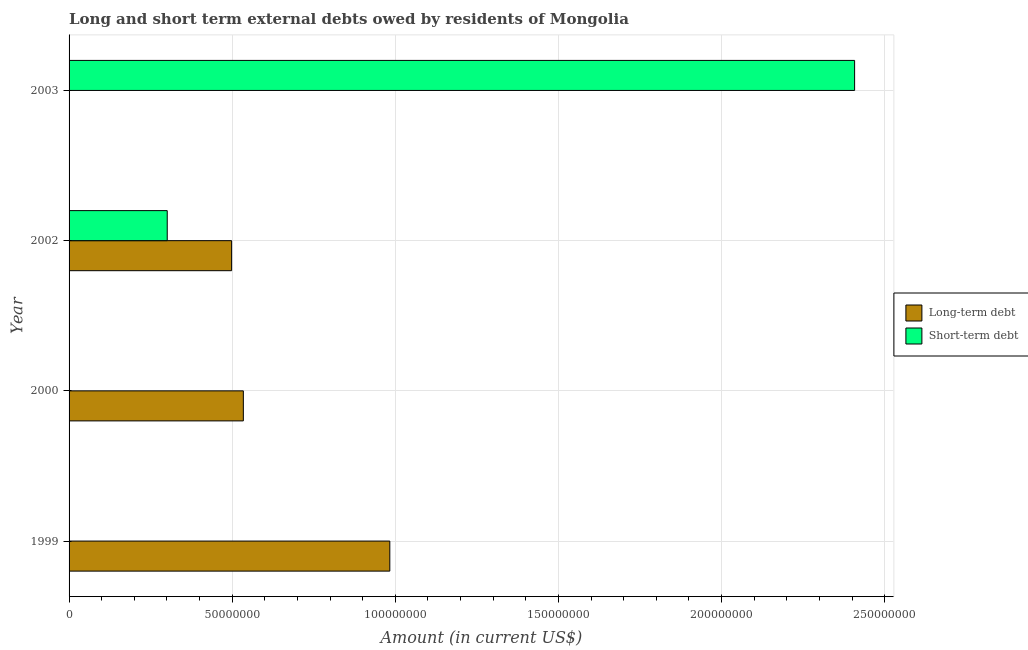How many different coloured bars are there?
Provide a short and direct response. 2. Are the number of bars per tick equal to the number of legend labels?
Your answer should be compact. No. Are the number of bars on each tick of the Y-axis equal?
Provide a succinct answer. No. How many bars are there on the 3rd tick from the bottom?
Your response must be concise. 2. What is the short-term debts owed by residents in 2002?
Provide a short and direct response. 3.01e+07. Across all years, what is the maximum long-term debts owed by residents?
Your response must be concise. 9.83e+07. What is the total short-term debts owed by residents in the graph?
Offer a terse response. 2.71e+08. What is the difference between the long-term debts owed by residents in 2000 and that in 2002?
Offer a very short reply. 3.60e+06. What is the average long-term debts owed by residents per year?
Offer a terse response. 5.04e+07. In the year 2002, what is the difference between the long-term debts owed by residents and short-term debts owed by residents?
Offer a terse response. 1.97e+07. In how many years, is the long-term debts owed by residents greater than 210000000 US$?
Give a very brief answer. 0. What is the ratio of the long-term debts owed by residents in 2000 to that in 2002?
Offer a very short reply. 1.07. What is the difference between the highest and the second highest long-term debts owed by residents?
Ensure brevity in your answer.  4.49e+07. What is the difference between the highest and the lowest long-term debts owed by residents?
Your answer should be compact. 9.83e+07. In how many years, is the short-term debts owed by residents greater than the average short-term debts owed by residents taken over all years?
Your answer should be compact. 1. Is the sum of the long-term debts owed by residents in 1999 and 2000 greater than the maximum short-term debts owed by residents across all years?
Your response must be concise. No. How many bars are there?
Your answer should be very brief. 5. Are all the bars in the graph horizontal?
Provide a succinct answer. Yes. What is the difference between two consecutive major ticks on the X-axis?
Provide a succinct answer. 5.00e+07. Are the values on the major ticks of X-axis written in scientific E-notation?
Provide a succinct answer. No. Where does the legend appear in the graph?
Offer a very short reply. Center right. What is the title of the graph?
Make the answer very short. Long and short term external debts owed by residents of Mongolia. What is the label or title of the X-axis?
Keep it short and to the point. Amount (in current US$). What is the Amount (in current US$) of Long-term debt in 1999?
Your response must be concise. 9.83e+07. What is the Amount (in current US$) in Short-term debt in 1999?
Provide a short and direct response. 0. What is the Amount (in current US$) of Long-term debt in 2000?
Provide a succinct answer. 5.34e+07. What is the Amount (in current US$) in Long-term debt in 2002?
Make the answer very short. 4.98e+07. What is the Amount (in current US$) of Short-term debt in 2002?
Offer a terse response. 3.01e+07. What is the Amount (in current US$) in Long-term debt in 2003?
Your response must be concise. 0. What is the Amount (in current US$) in Short-term debt in 2003?
Make the answer very short. 2.41e+08. Across all years, what is the maximum Amount (in current US$) in Long-term debt?
Give a very brief answer. 9.83e+07. Across all years, what is the maximum Amount (in current US$) of Short-term debt?
Your answer should be very brief. 2.41e+08. Across all years, what is the minimum Amount (in current US$) of Long-term debt?
Give a very brief answer. 0. What is the total Amount (in current US$) of Long-term debt in the graph?
Your answer should be compact. 2.02e+08. What is the total Amount (in current US$) in Short-term debt in the graph?
Your answer should be compact. 2.71e+08. What is the difference between the Amount (in current US$) of Long-term debt in 1999 and that in 2000?
Make the answer very short. 4.49e+07. What is the difference between the Amount (in current US$) in Long-term debt in 1999 and that in 2002?
Your answer should be compact. 4.85e+07. What is the difference between the Amount (in current US$) in Long-term debt in 2000 and that in 2002?
Ensure brevity in your answer.  3.60e+06. What is the difference between the Amount (in current US$) in Short-term debt in 2002 and that in 2003?
Your answer should be very brief. -2.11e+08. What is the difference between the Amount (in current US$) of Long-term debt in 1999 and the Amount (in current US$) of Short-term debt in 2002?
Your answer should be compact. 6.82e+07. What is the difference between the Amount (in current US$) of Long-term debt in 1999 and the Amount (in current US$) of Short-term debt in 2003?
Give a very brief answer. -1.42e+08. What is the difference between the Amount (in current US$) in Long-term debt in 2000 and the Amount (in current US$) in Short-term debt in 2002?
Ensure brevity in your answer.  2.33e+07. What is the difference between the Amount (in current US$) in Long-term debt in 2000 and the Amount (in current US$) in Short-term debt in 2003?
Your answer should be compact. -1.87e+08. What is the difference between the Amount (in current US$) in Long-term debt in 2002 and the Amount (in current US$) in Short-term debt in 2003?
Your response must be concise. -1.91e+08. What is the average Amount (in current US$) of Long-term debt per year?
Your answer should be compact. 5.04e+07. What is the average Amount (in current US$) of Short-term debt per year?
Your answer should be compact. 6.77e+07. In the year 2002, what is the difference between the Amount (in current US$) in Long-term debt and Amount (in current US$) in Short-term debt?
Make the answer very short. 1.97e+07. What is the ratio of the Amount (in current US$) in Long-term debt in 1999 to that in 2000?
Your answer should be compact. 1.84. What is the ratio of the Amount (in current US$) of Long-term debt in 1999 to that in 2002?
Offer a very short reply. 1.97. What is the ratio of the Amount (in current US$) in Long-term debt in 2000 to that in 2002?
Provide a short and direct response. 1.07. What is the ratio of the Amount (in current US$) of Short-term debt in 2002 to that in 2003?
Provide a short and direct response. 0.12. What is the difference between the highest and the second highest Amount (in current US$) of Long-term debt?
Keep it short and to the point. 4.49e+07. What is the difference between the highest and the lowest Amount (in current US$) of Long-term debt?
Your answer should be compact. 9.83e+07. What is the difference between the highest and the lowest Amount (in current US$) in Short-term debt?
Your answer should be compact. 2.41e+08. 